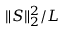Convert formula to latex. <formula><loc_0><loc_0><loc_500><loc_500>\| S \| _ { 2 } ^ { 2 } / L</formula> 